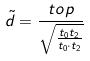Convert formula to latex. <formula><loc_0><loc_0><loc_500><loc_500>\tilde { d } = \frac { t o p } { \sqrt { \frac { t _ { 0 } t _ { 2 } } { t _ { 0 } \cdot t _ { 2 } } } }</formula> 